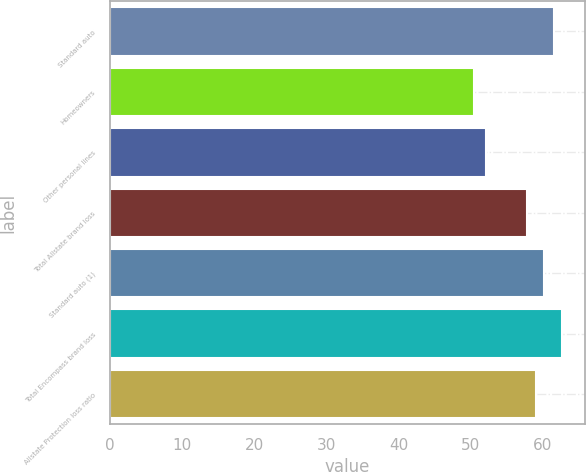Convert chart to OTSL. <chart><loc_0><loc_0><loc_500><loc_500><bar_chart><fcel>Standard auto<fcel>Homeowners<fcel>Other personal lines<fcel>Total Allstate brand loss<fcel>Standard auto (1)<fcel>Total Encompass brand loss<fcel>Allstate Protection loss ratio<nl><fcel>61.5<fcel>50.4<fcel>52.1<fcel>57.8<fcel>60.14<fcel>62.67<fcel>58.97<nl></chart> 